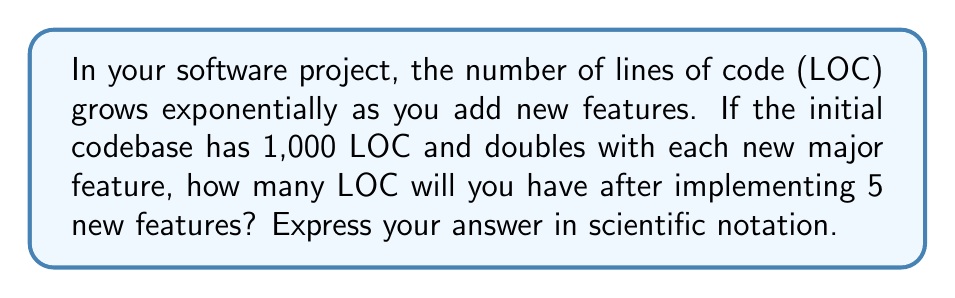Could you help me with this problem? Let's approach this step-by-step:

1) We start with 1,000 LOC.

2) The codebase doubles with each new feature. This can be represented as an exponential function:

   $$ LOC = 1000 \cdot 2^n $$

   Where $n$ is the number of new features.

3) We're implementing 5 new features, so $n = 5$:

   $$ LOC = 1000 \cdot 2^5 $$

4) Let's calculate $2^5$:
   
   $$ 2^5 = 2 \cdot 2 \cdot 2 \cdot 2 \cdot 2 = 32 $$

5) Now our equation looks like:

   $$ LOC = 1000 \cdot 32 $$

6) Multiply:

   $$ LOC = 32,000 $$

7) To express this in scientific notation, we move the decimal point 4 places to the left:

   $$ LOC = 3.2 \cdot 10^4 $$

This exponential growth demonstrates how quickly code complexity can increase as a project scales, highlighting the importance of efficient code management and modular design in software development.
Answer: $3.2 \cdot 10^4$ LOC 